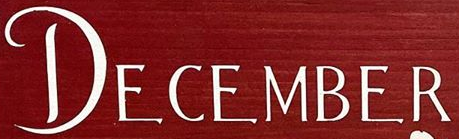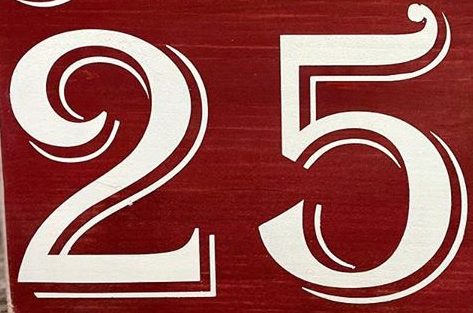Identify the words shown in these images in order, separated by a semicolon. DECEMBER; 25 